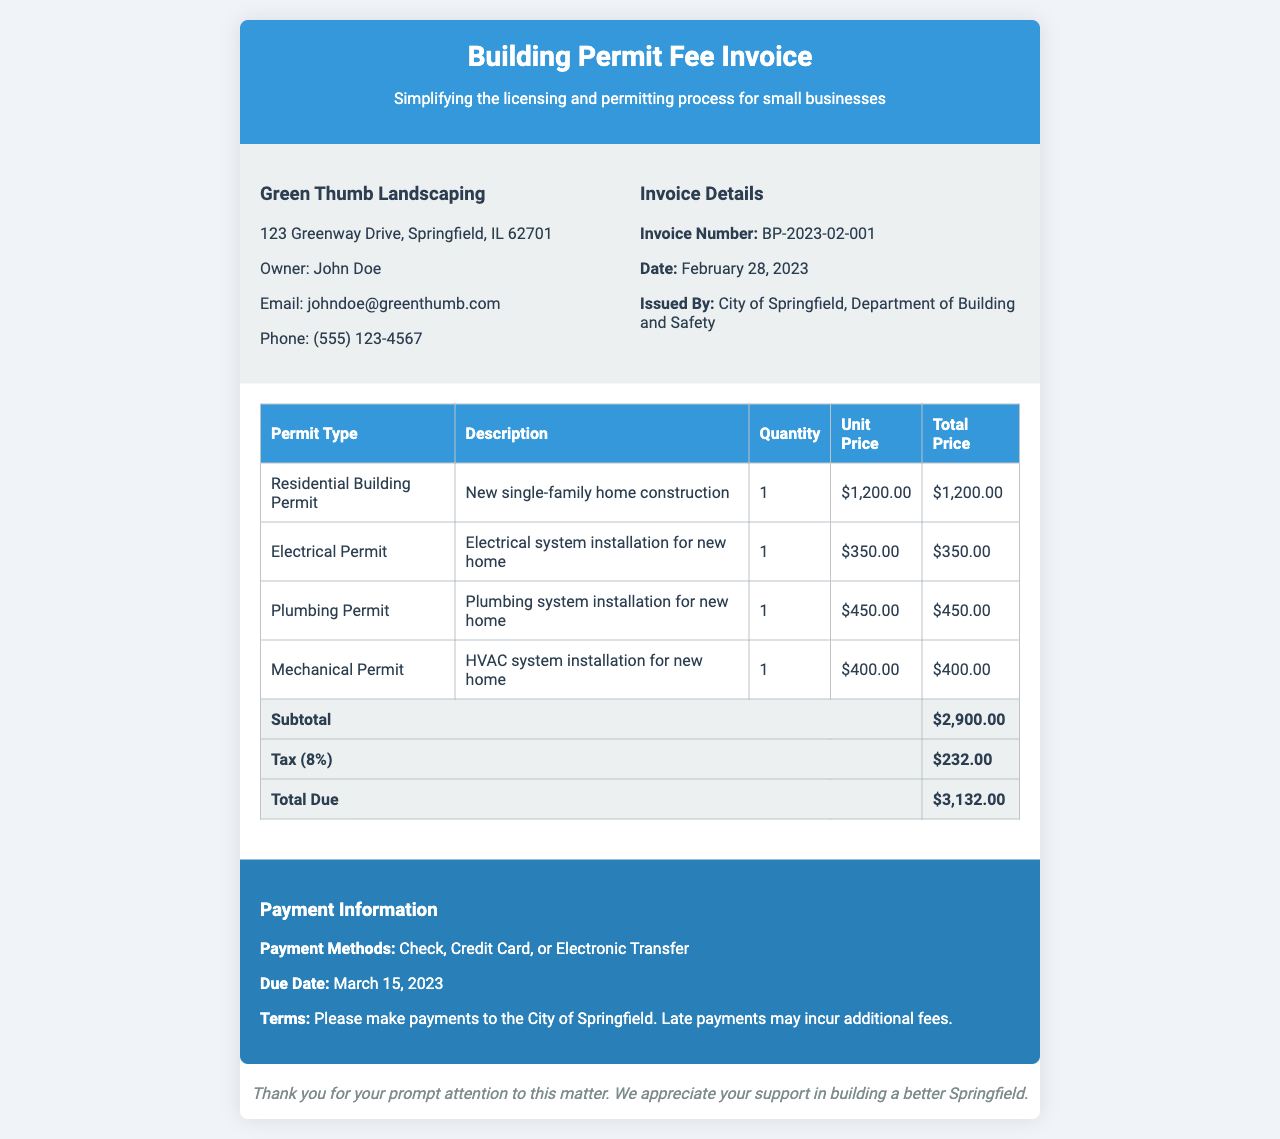What is the total due amount? The total due amount is indicated at the end of the invoice, which includes the subtotal and tax.
Answer: $3,132.00 What is the invoice number? The invoice number is prominently displayed in the invoice details section.
Answer: BP-2023-02-001 Who is the owner of Green Thumb Landscaping? The owner's name is listed in the business info section of the invoice.
Answer: John Doe What is the tax rate applied to the invoice? The tax information states that 8% was applied to the subtotal for the invoice.
Answer: 8% How many permits are listed in the invoice? The invoice provides a breakdown of various permits, which can be counted from the table.
Answer: 4 What is the due date for the payment? The due date for the payment is provided in the payment information section of the invoice.
Answer: March 15, 2023 What is the total price for the Electrical Permit? The total price for the Electrical Permit is extracted from the table under permit types.
Answer: $350.00 What methods of payment are accepted? The payment information specifies the accepted payment methods clearly.
Answer: Check, Credit Card, or Electronic Transfer What type of permit is the first item listed? The first item in the table of permits indicates the type of permit listed.
Answer: Residential Building Permit 